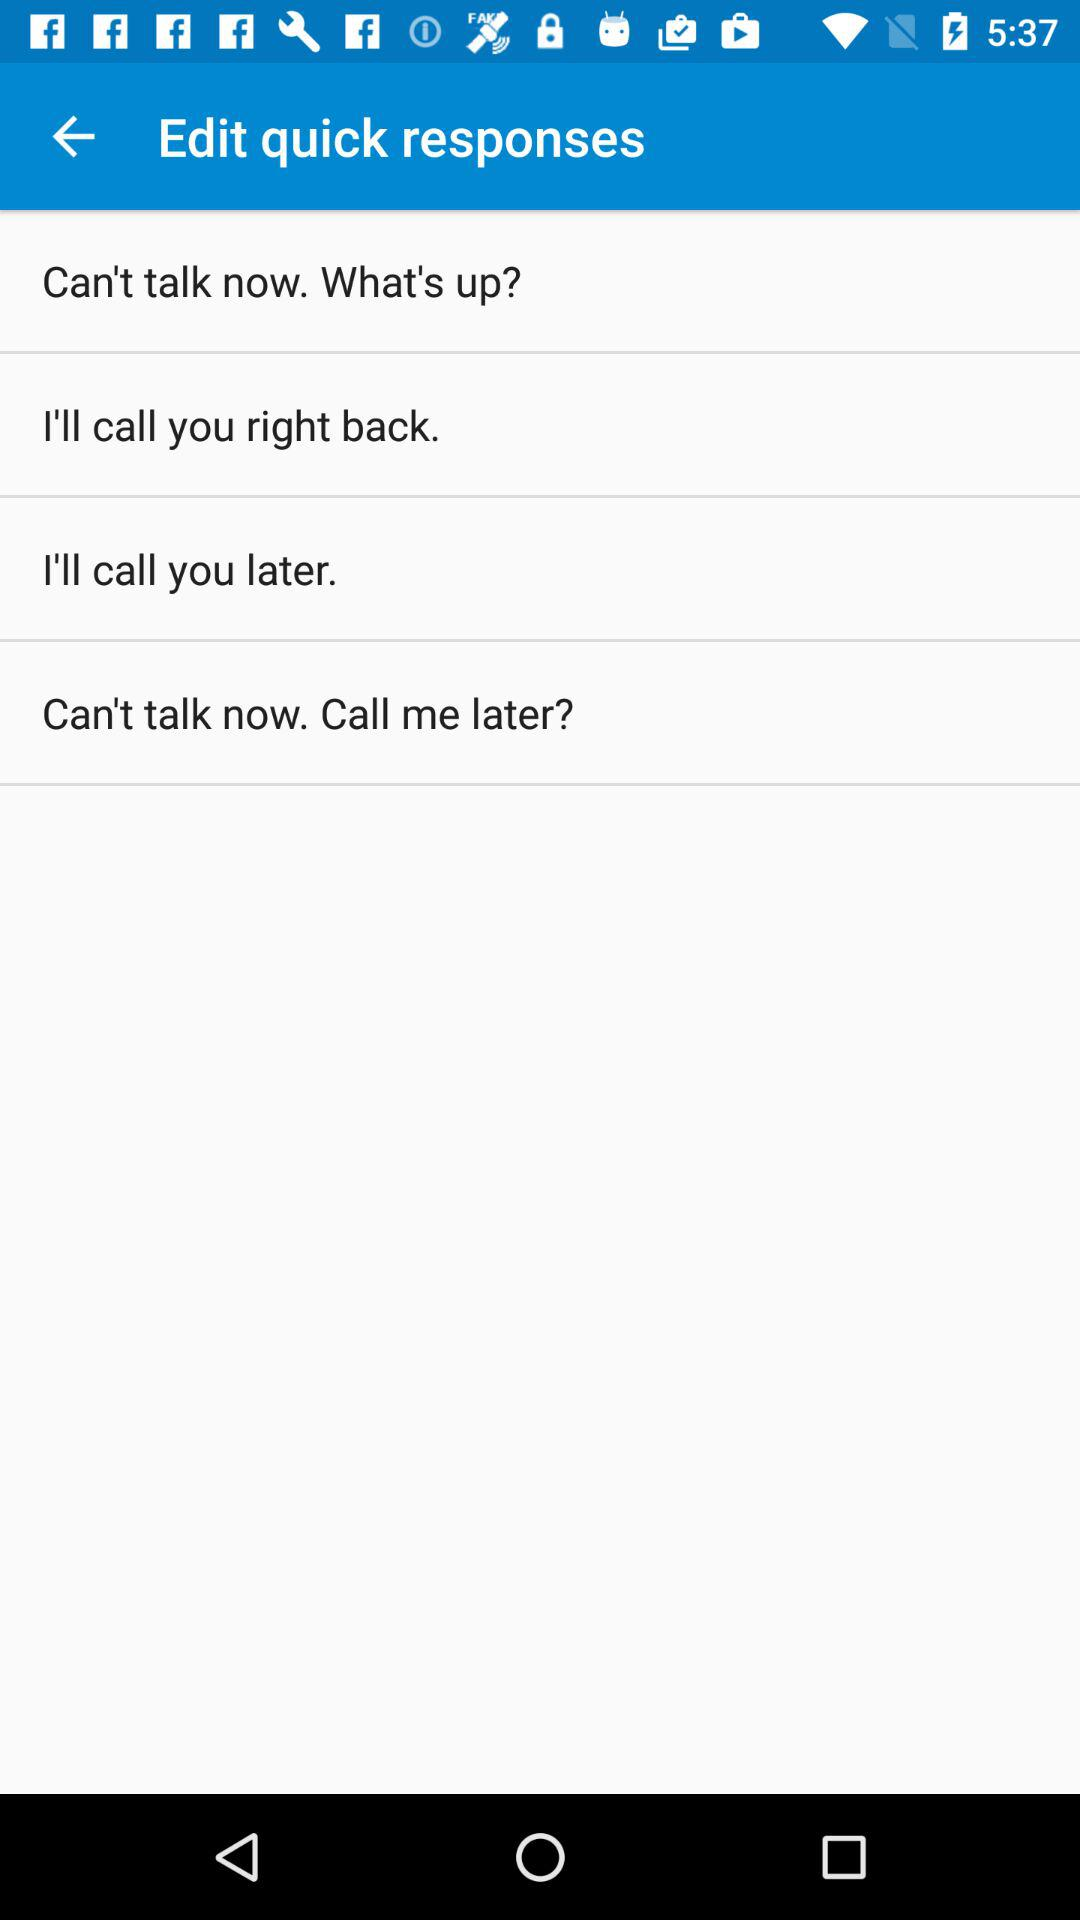How many quick responses are there?
Answer the question using a single word or phrase. 4 